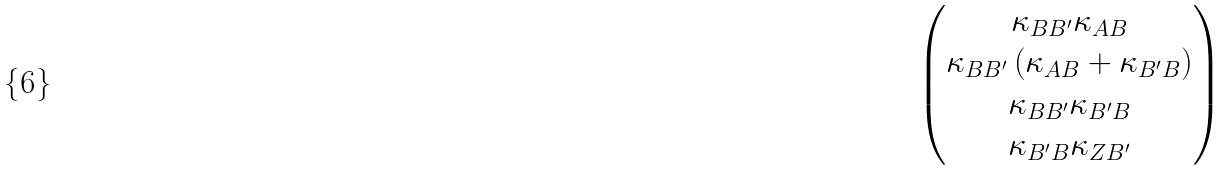Convert formula to latex. <formula><loc_0><loc_0><loc_500><loc_500>\begin{pmatrix} \kappa _ { B B ^ { \prime } } \kappa _ { A B } \\ \kappa _ { B B ^ { \prime } } \left ( \kappa _ { A B } + \kappa _ { B ^ { \prime } B } \right ) \\ \kappa _ { B B ^ { \prime } } \kappa _ { B ^ { \prime } B } \\ \kappa _ { B ^ { \prime } B } \kappa _ { Z B ^ { \prime } } \end{pmatrix}</formula> 